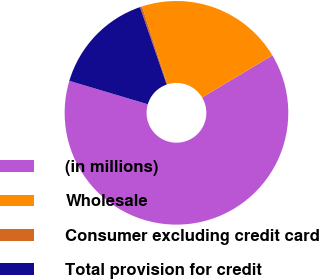<chart> <loc_0><loc_0><loc_500><loc_500><pie_chart><fcel>(in millions)<fcel>Wholesale<fcel>Consumer excluding credit card<fcel>Total provision for credit<nl><fcel>63.2%<fcel>21.39%<fcel>0.31%<fcel>15.1%<nl></chart> 